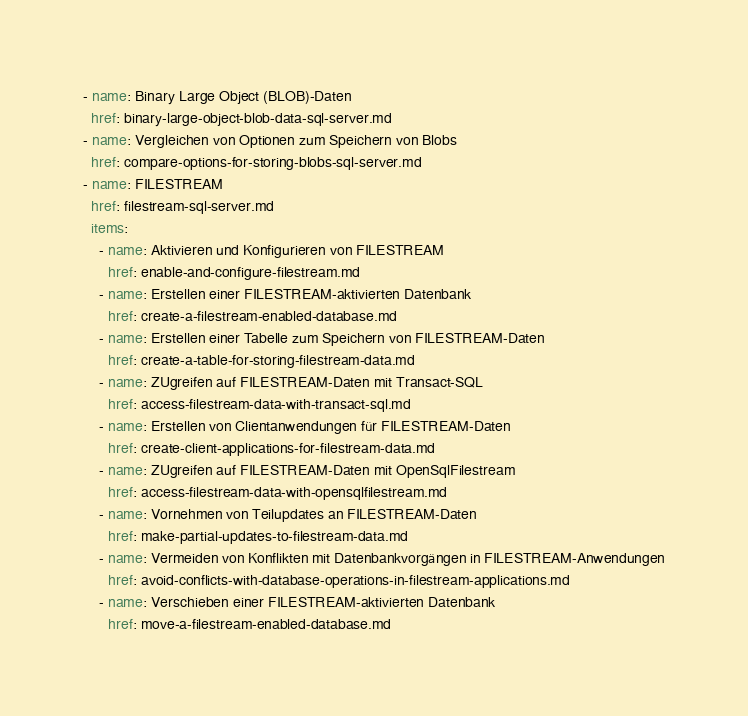<code> <loc_0><loc_0><loc_500><loc_500><_YAML_>- name: Binary Large Object (BLOB)-Daten
  href: binary-large-object-blob-data-sql-server.md
- name: Vergleichen von Optionen zum Speichern von Blobs
  href: compare-options-for-storing-blobs-sql-server.md
- name: FILESTREAM
  href: filestream-sql-server.md
  items:
    - name: Aktivieren und Konfigurieren von FILESTREAM
      href: enable-and-configure-filestream.md
    - name: Erstellen einer FILESTREAM-aktivierten Datenbank
      href: create-a-filestream-enabled-database.md
    - name: Erstellen einer Tabelle zum Speichern von FILESTREAM-Daten
      href: create-a-table-for-storing-filestream-data.md
    - name: ZUgreifen auf FILESTREAM-Daten mit Transact-SQL
      href: access-filestream-data-with-transact-sql.md
    - name: Erstellen von Clientanwendungen für FILESTREAM-Daten
      href: create-client-applications-for-filestream-data.md
    - name: ZUgreifen auf FILESTREAM-Daten mit OpenSqlFilestream
      href: access-filestream-data-with-opensqlfilestream.md
    - name: Vornehmen von Teilupdates an FILESTREAM-Daten
      href: make-partial-updates-to-filestream-data.md
    - name: Vermeiden von Konflikten mit Datenbankvorgängen in FILESTREAM-Anwendungen
      href: avoid-conflicts-with-database-operations-in-filestream-applications.md
    - name: Verschieben einer FILESTREAM-aktivierten Datenbank
      href: move-a-filestream-enabled-database.md</code> 